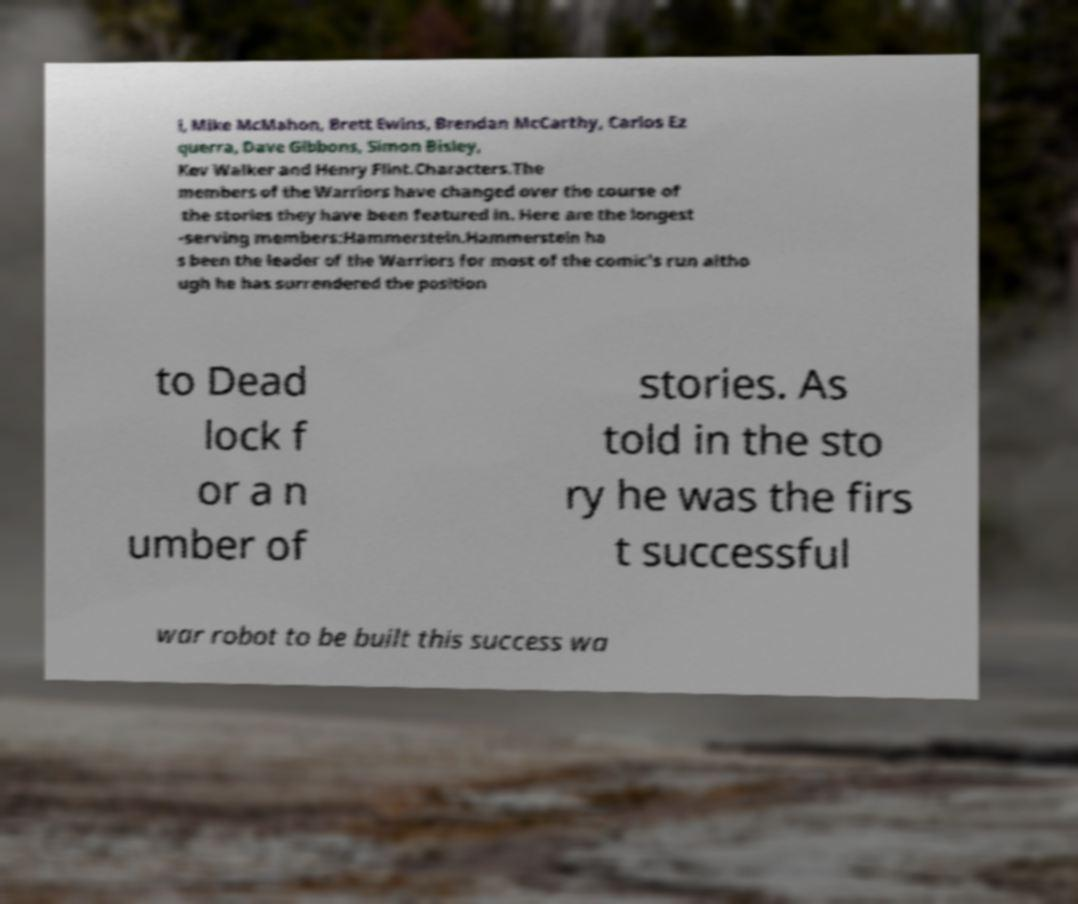What messages or text are displayed in this image? I need them in a readable, typed format. l, Mike McMahon, Brett Ewins, Brendan McCarthy, Carlos Ez querra, Dave Gibbons, Simon Bisley, Kev Walker and Henry Flint.Characters.The members of the Warriors have changed over the course of the stories they have been featured in. Here are the longest -serving members:Hammerstein.Hammerstein ha s been the leader of the Warriors for most of the comic's run altho ugh he has surrendered the position to Dead lock f or a n umber of stories. As told in the sto ry he was the firs t successful war robot to be built this success wa 